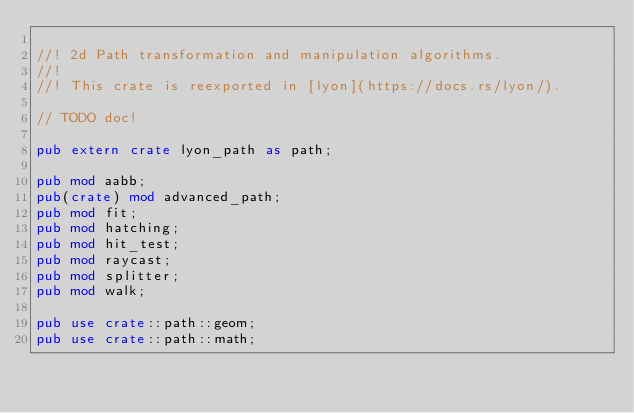<code> <loc_0><loc_0><loc_500><loc_500><_Rust_>
//! 2d Path transformation and manipulation algorithms.
//!
//! This crate is reexported in [lyon](https://docs.rs/lyon/).

// TODO doc!

pub extern crate lyon_path as path;

pub mod aabb;
pub(crate) mod advanced_path;
pub mod fit;
pub mod hatching;
pub mod hit_test;
pub mod raycast;
pub mod splitter;
pub mod walk;

pub use crate::path::geom;
pub use crate::path::math;
</code> 